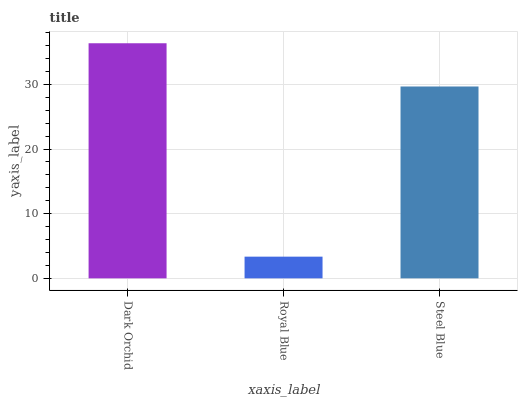Is Royal Blue the minimum?
Answer yes or no. Yes. Is Dark Orchid the maximum?
Answer yes or no. Yes. Is Steel Blue the minimum?
Answer yes or no. No. Is Steel Blue the maximum?
Answer yes or no. No. Is Steel Blue greater than Royal Blue?
Answer yes or no. Yes. Is Royal Blue less than Steel Blue?
Answer yes or no. Yes. Is Royal Blue greater than Steel Blue?
Answer yes or no. No. Is Steel Blue less than Royal Blue?
Answer yes or no. No. Is Steel Blue the high median?
Answer yes or no. Yes. Is Steel Blue the low median?
Answer yes or no. Yes. Is Royal Blue the high median?
Answer yes or no. No. Is Royal Blue the low median?
Answer yes or no. No. 